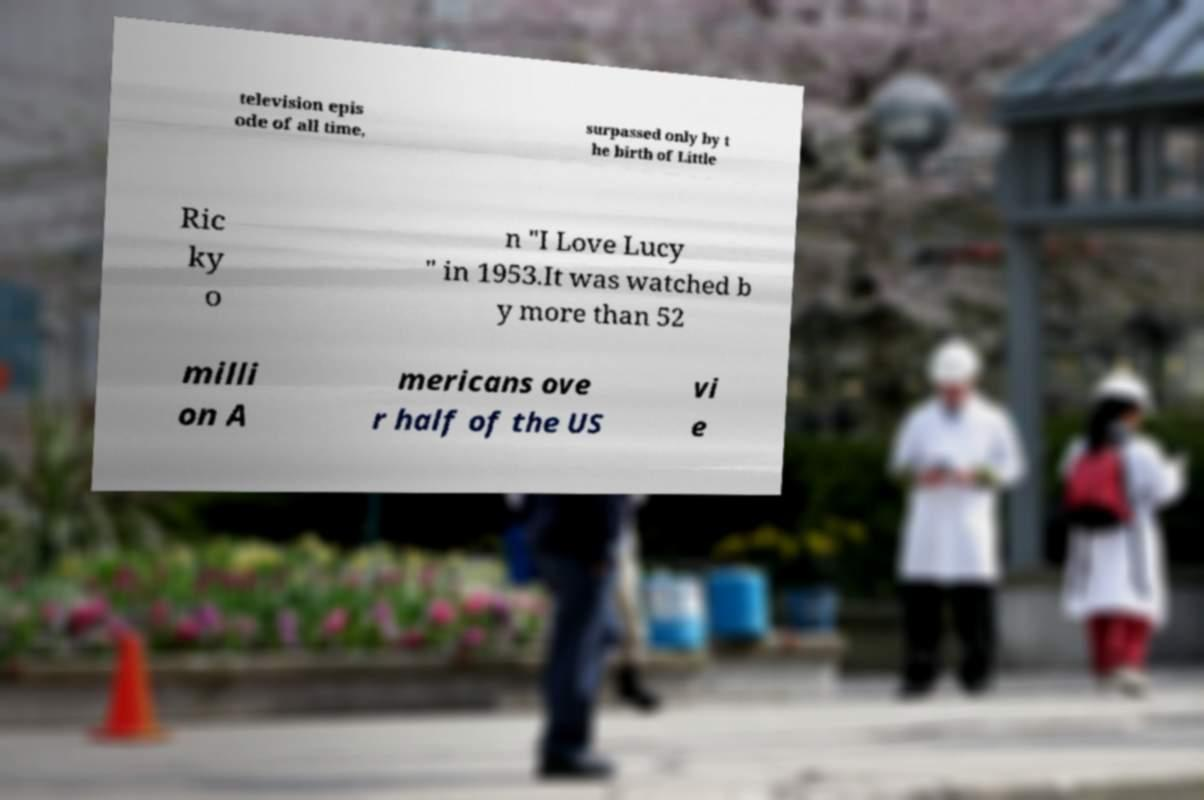Could you extract and type out the text from this image? television epis ode of all time, surpassed only by t he birth of Little Ric ky o n "I Love Lucy " in 1953.It was watched b y more than 52 milli on A mericans ove r half of the US vi e 